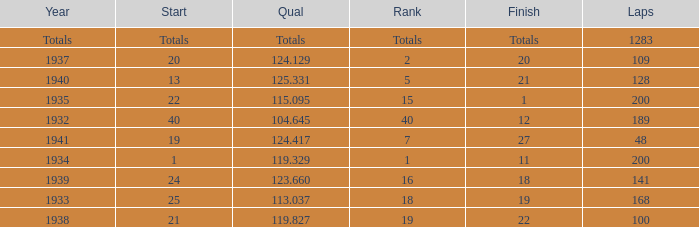What year did he start at 13? 1940.0. 